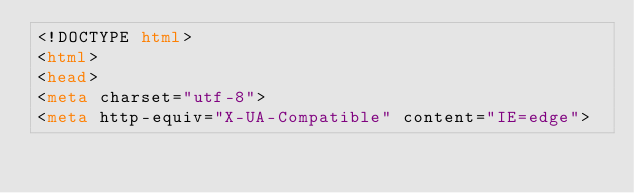Convert code to text. <code><loc_0><loc_0><loc_500><loc_500><_HTML_><!DOCTYPE html>
<html>
<head>
<meta charset="utf-8">
<meta http-equiv="X-UA-Compatible" content="IE=edge"></code> 